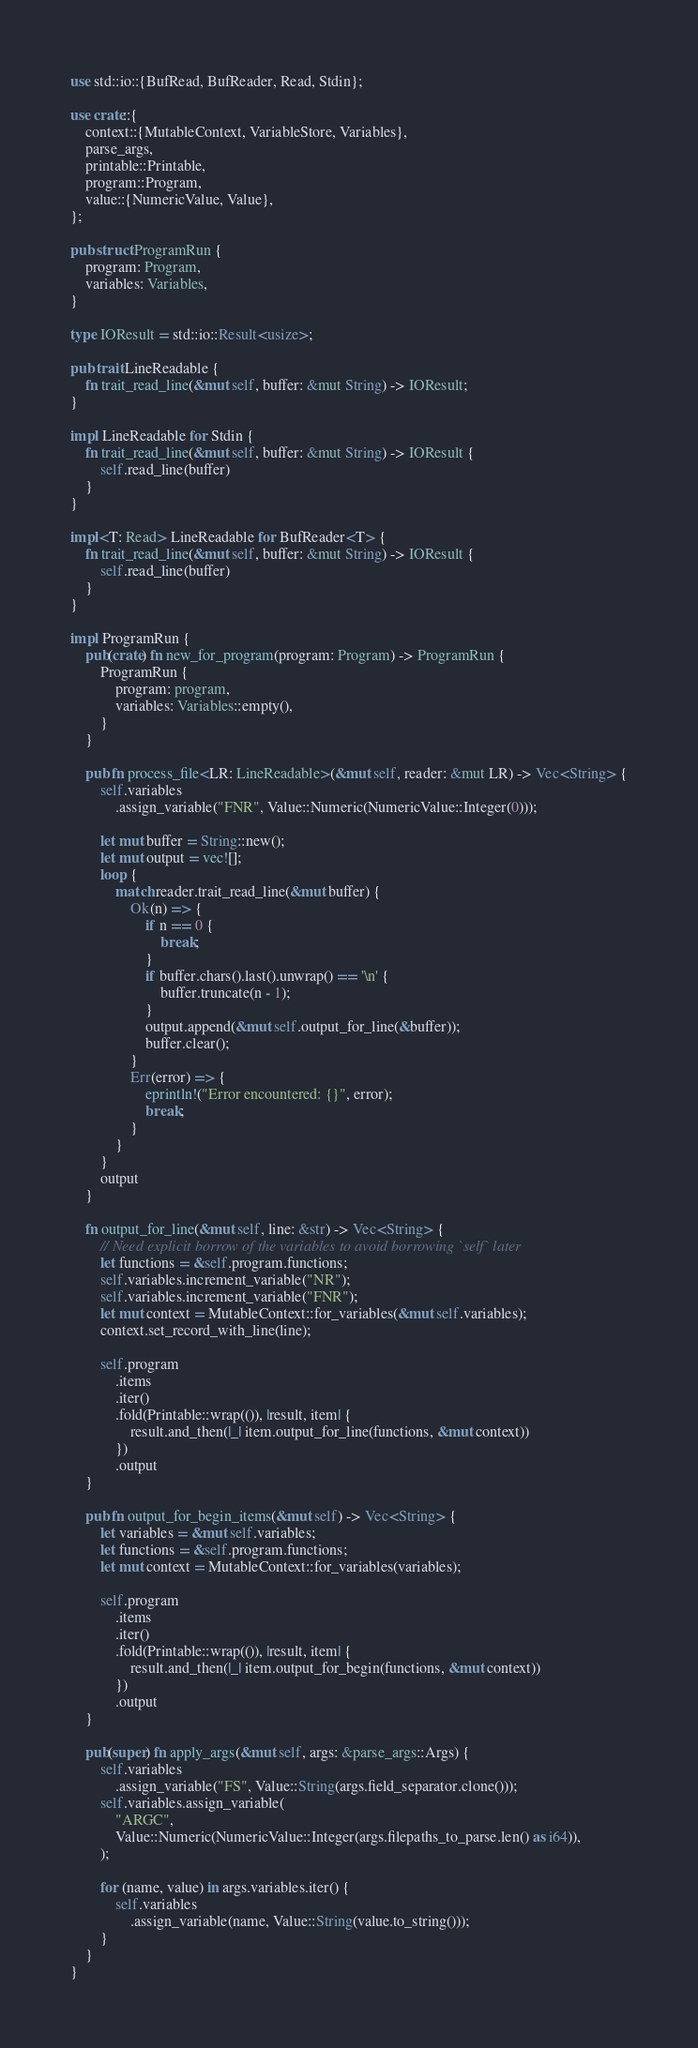<code> <loc_0><loc_0><loc_500><loc_500><_Rust_>use std::io::{BufRead, BufReader, Read, Stdin};

use crate::{
    context::{MutableContext, VariableStore, Variables},
    parse_args,
    printable::Printable,
    program::Program,
    value::{NumericValue, Value},
};

pub struct ProgramRun {
    program: Program,
    variables: Variables,
}

type IOResult = std::io::Result<usize>;

pub trait LineReadable {
    fn trait_read_line(&mut self, buffer: &mut String) -> IOResult;
}

impl LineReadable for Stdin {
    fn trait_read_line(&mut self, buffer: &mut String) -> IOResult {
        self.read_line(buffer)
    }
}

impl<T: Read> LineReadable for BufReader<T> {
    fn trait_read_line(&mut self, buffer: &mut String) -> IOResult {
        self.read_line(buffer)
    }
}

impl ProgramRun {
    pub(crate) fn new_for_program(program: Program) -> ProgramRun {
        ProgramRun {
            program: program,
            variables: Variables::empty(),
        }
    }

    pub fn process_file<LR: LineReadable>(&mut self, reader: &mut LR) -> Vec<String> {
        self.variables
            .assign_variable("FNR", Value::Numeric(NumericValue::Integer(0)));

        let mut buffer = String::new();
        let mut output = vec![];
        loop {
            match reader.trait_read_line(&mut buffer) {
                Ok(n) => {
                    if n == 0 {
                        break;
                    }
                    if buffer.chars().last().unwrap() == '\n' {
                        buffer.truncate(n - 1);
                    }
                    output.append(&mut self.output_for_line(&buffer));
                    buffer.clear();
                }
                Err(error) => {
                    eprintln!("Error encountered: {}", error);
                    break;
                }
            }
        }
        output
    }

    fn output_for_line(&mut self, line: &str) -> Vec<String> {
        // Need explicit borrow of the variables to avoid borrowing `self` later
        let functions = &self.program.functions;
        self.variables.increment_variable("NR");
        self.variables.increment_variable("FNR");
        let mut context = MutableContext::for_variables(&mut self.variables);
        context.set_record_with_line(line);

        self.program
            .items
            .iter()
            .fold(Printable::wrap(()), |result, item| {
                result.and_then(|_| item.output_for_line(functions, &mut context))
            })
            .output
    }

    pub fn output_for_begin_items(&mut self) -> Vec<String> {
        let variables = &mut self.variables;
        let functions = &self.program.functions;
        let mut context = MutableContext::for_variables(variables);

        self.program
            .items
            .iter()
            .fold(Printable::wrap(()), |result, item| {
                result.and_then(|_| item.output_for_begin(functions, &mut context))
            })
            .output
    }

    pub(super) fn apply_args(&mut self, args: &parse_args::Args) {
        self.variables
            .assign_variable("FS", Value::String(args.field_separator.clone()));
        self.variables.assign_variable(
            "ARGC",
            Value::Numeric(NumericValue::Integer(args.filepaths_to_parse.len() as i64)),
        );

        for (name, value) in args.variables.iter() {
            self.variables
                .assign_variable(name, Value::String(value.to_string()));
        }
    }
}
</code> 